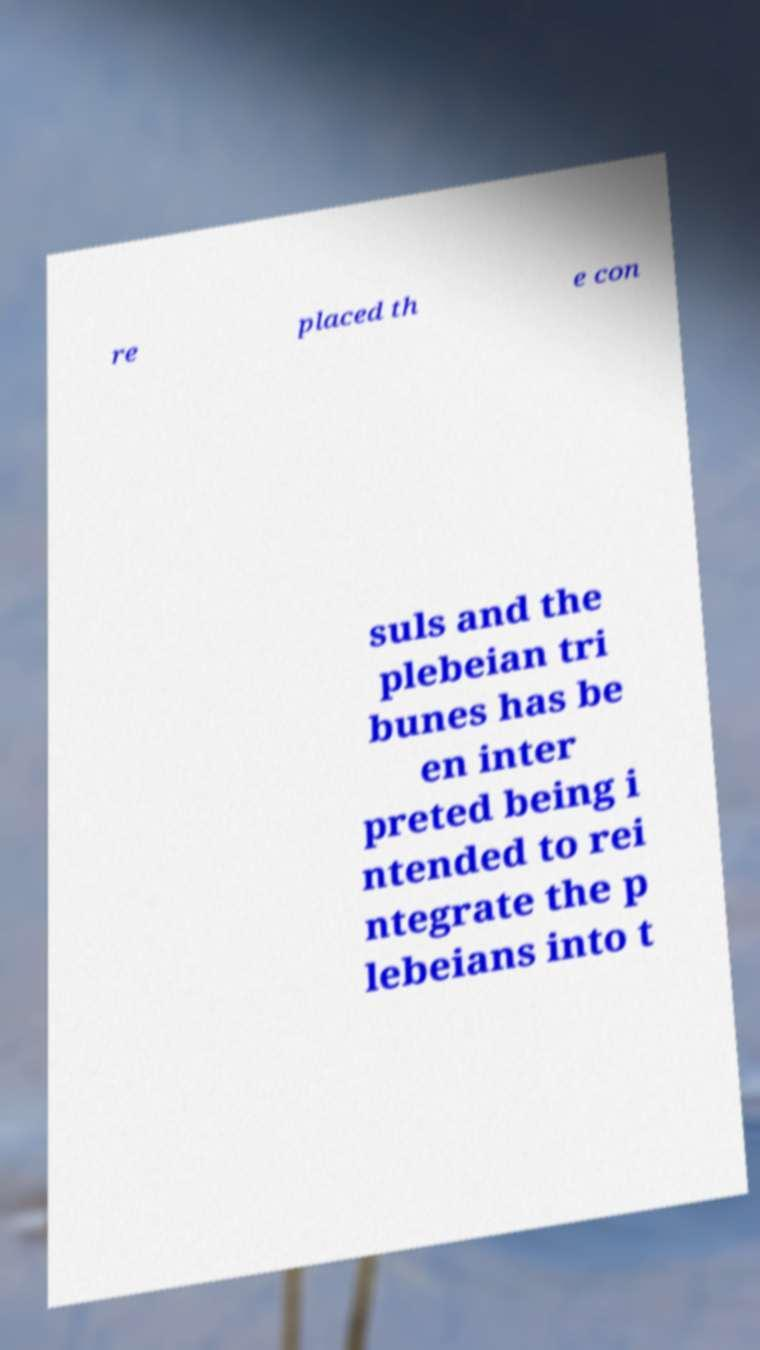For documentation purposes, I need the text within this image transcribed. Could you provide that? re placed th e con suls and the plebeian tri bunes has be en inter preted being i ntended to rei ntegrate the p lebeians into t 